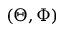<formula> <loc_0><loc_0><loc_500><loc_500>( \Theta , \Phi )</formula> 